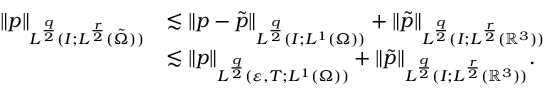Convert formula to latex. <formula><loc_0><loc_0><loc_500><loc_500>\begin{array} { r l } { \| p \| _ { L ^ { \frac { q } { 2 } } ( I ; L ^ { \frac { r } { 2 } } ( \tilde { \Omega } ) ) } } & { \lesssim \| p - \tilde { p } \| _ { L ^ { \frac { q } { 2 } } ( I ; L ^ { 1 } ( \Omega ) ) } + \| \tilde { p } \| _ { L ^ { \frac { q } { 2 } } ( I ; L ^ { \frac { r } { 2 } } ( { \mathbb { R } } ^ { 3 } ) ) } } \\ & { \lesssim \| p \| _ { L ^ { \frac { q } { 2 } } ( \varepsilon , T ; L ^ { 1 } ( \Omega ) ) } + \| \tilde { p } \| _ { L ^ { \frac { q } { 2 } } ( I ; L ^ { \frac { r } { 2 } } ( { \mathbb { R } } ^ { 3 } ) ) } . } \end{array}</formula> 